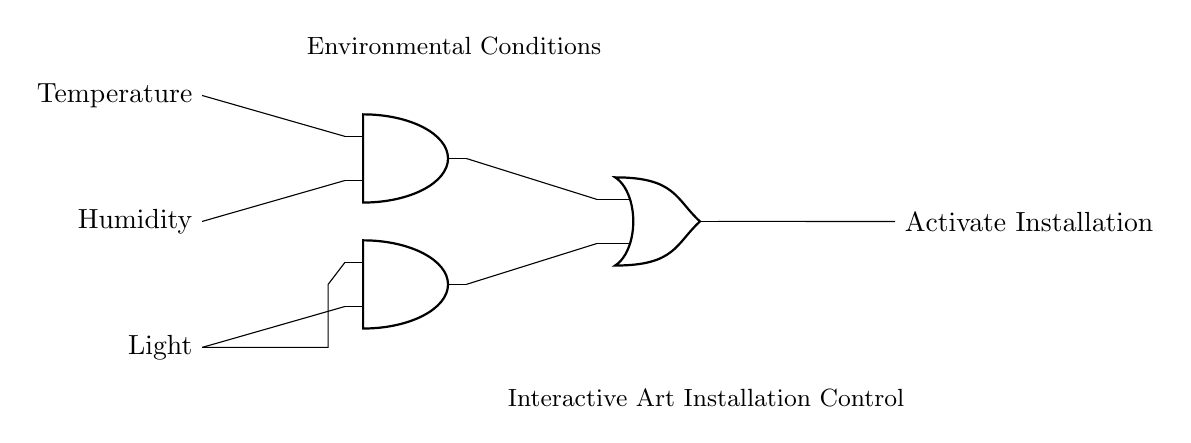What are the inputs to this circuit? The circuit has three inputs which are labeled as Temperature, Humidity, and Light. These inputs are essential for determining the environmental conditions that will control the interactive art installation.
Answer: Temperature, Humidity, Light How many AND gates are in the circuit? The circuit contains two AND gates, which are used to process the inputs from the sensors. Each AND gate combines a specific set of inputs before passing the output to the OR gate.
Answer: Two What is the output of the OR gate? The output of the OR gate is labeled as "Activate Installation," indicating that it will trigger the mechanism of the interactive art installation based on the processed inputs.
Answer: Activate Installation Which inputs affect the first AND gate? The first AND gate is affected by the Temperature and Humidity inputs, as indicated by the connections drawn into the AND gate from these sensors.
Answer: Temperature and Humidity What is the role of the light sensor in the circuit? The light sensor is connected to the second AND gate, providing one of its inputs to determine if the light level meets the requirements for activating the installation. This indicates the importance of light in the environmental conditions assessment.
Answer: Provide input to the second AND gate If both AND gates output a signal, what is the final output? If both AND gates output a signal, the OR gate will reflect this by outputting the signal "Activate Installation," thus activating the installation if the conditions from either AND gate are true.
Answer: Activate Installation 